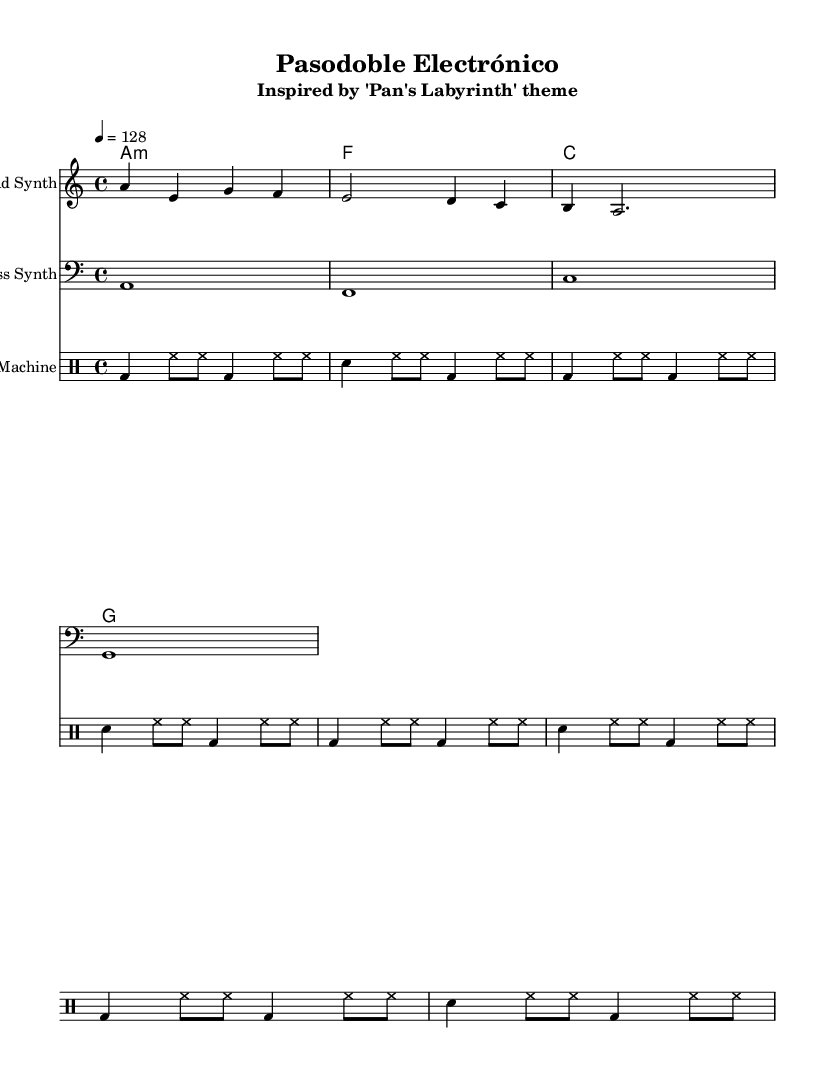What is the key signature of this music? The key signature is indicated before the time signature and shows one flat (A minor) in this piece.
Answer: A minor What is the time signature of this music? The time signature is shown at the beginning of the score, indicated as 4/4, meaning there are four beats per measure.
Answer: 4/4 What is the tempo marking of this piece? The tempo marking appears in text form, indicating that the beats should be played at a speed of 128 beats per minute.
Answer: 128 What instruments are included in this score? The score is divided into different staffs, each for a specific instrument: Lead Synth, Bass Synth, and Drum Machine. These can be found in their respective sections on the score.
Answer: Lead Synth, Bass Synth, Drum Machine What is the first note of the lead synth part? The lead synth part starts with an ‘A’ note, which can be seen at the beginning of the corresponding staff notation.
Answer: A How many measures are in the drum pattern? The drum pattern is repeated four times, and since each repetition contains four measures, the total number of measures in the drum pattern is calculated as 4 (repetitions) multiplied by 4 (measures) resulting in 16 measures.
Answer: 16 What chord is played in the second measure of the harmonies? The second measure of the harmonies indicates an F major chord, clearly denoted in the chord mode section of the score.
Answer: F major 